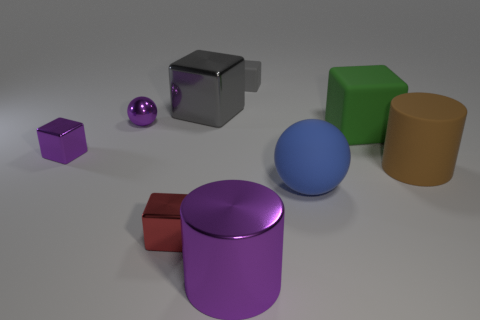Add 1 large brown cubes. How many objects exist? 10 Subtract all small shiny blocks. How many blocks are left? 3 Subtract all purple spheres. How many gray cubes are left? 2 Subtract all balls. How many objects are left? 7 Add 5 large gray blocks. How many large gray blocks are left? 6 Add 2 small red matte cylinders. How many small red matte cylinders exist? 2 Subtract all red cubes. How many cubes are left? 4 Subtract 0 cyan balls. How many objects are left? 9 Subtract 2 cylinders. How many cylinders are left? 0 Subtract all purple balls. Subtract all brown cubes. How many balls are left? 1 